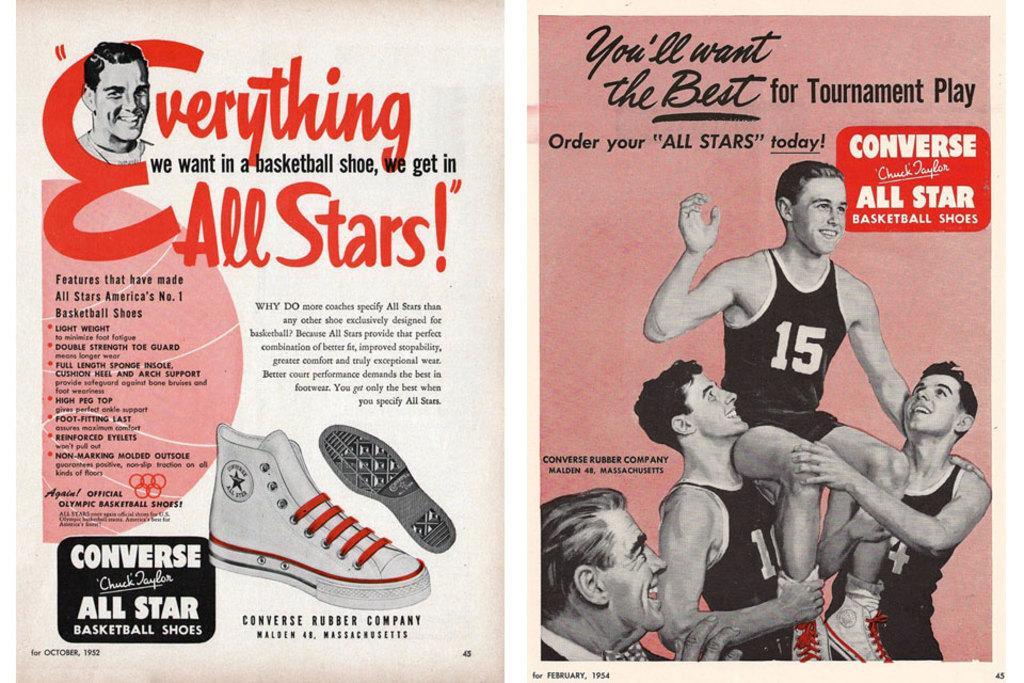Please provide a concise description of this image. In the foreground of this poster, on the left, there is some text and the image of shoes and a person. On the right, there are people and the text. 